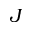<formula> <loc_0><loc_0><loc_500><loc_500>J</formula> 